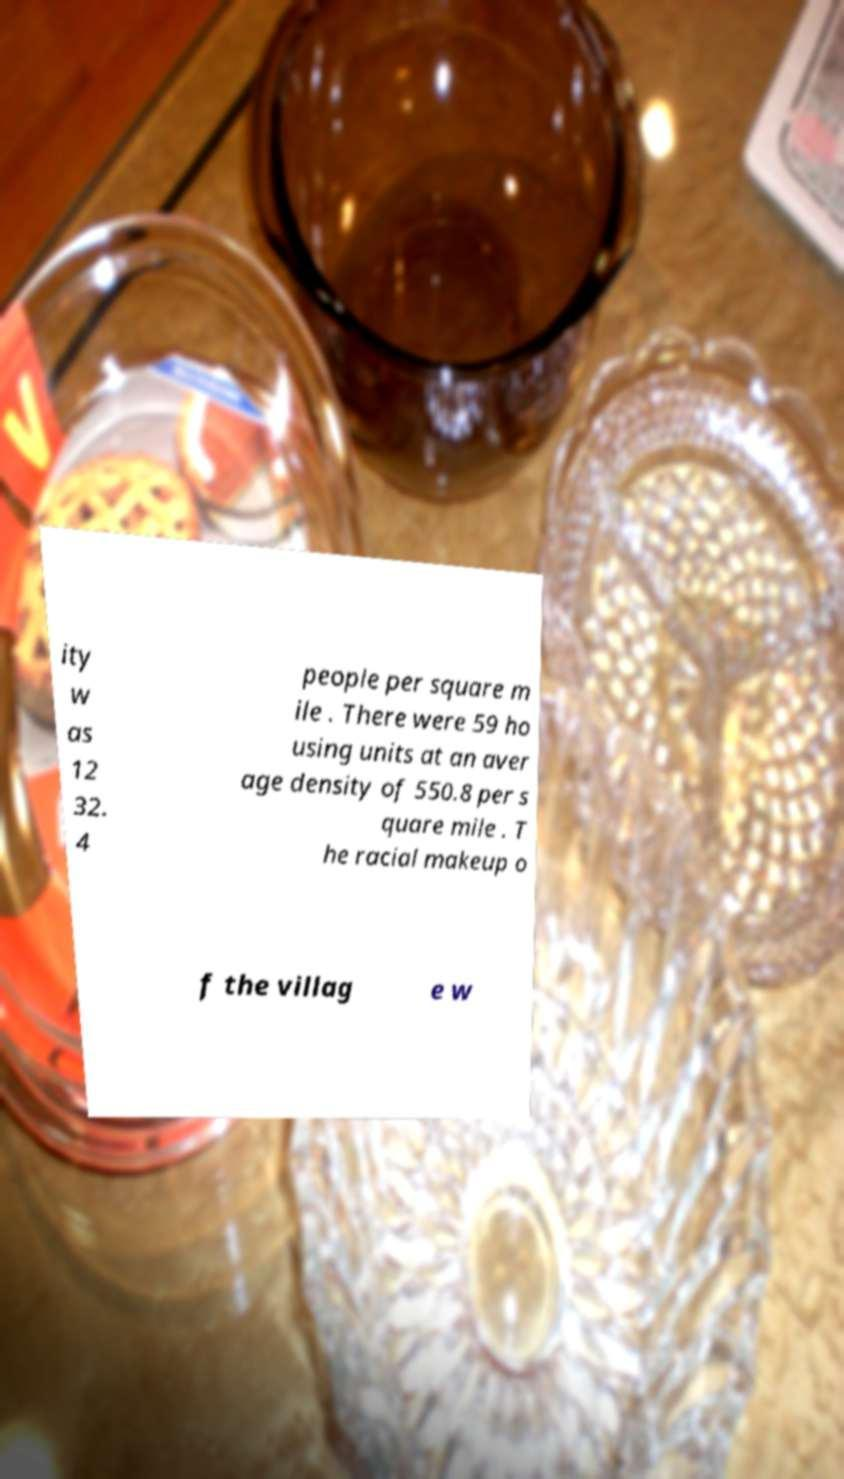Please identify and transcribe the text found in this image. ity w as 12 32. 4 people per square m ile . There were 59 ho using units at an aver age density of 550.8 per s quare mile . T he racial makeup o f the villag e w 